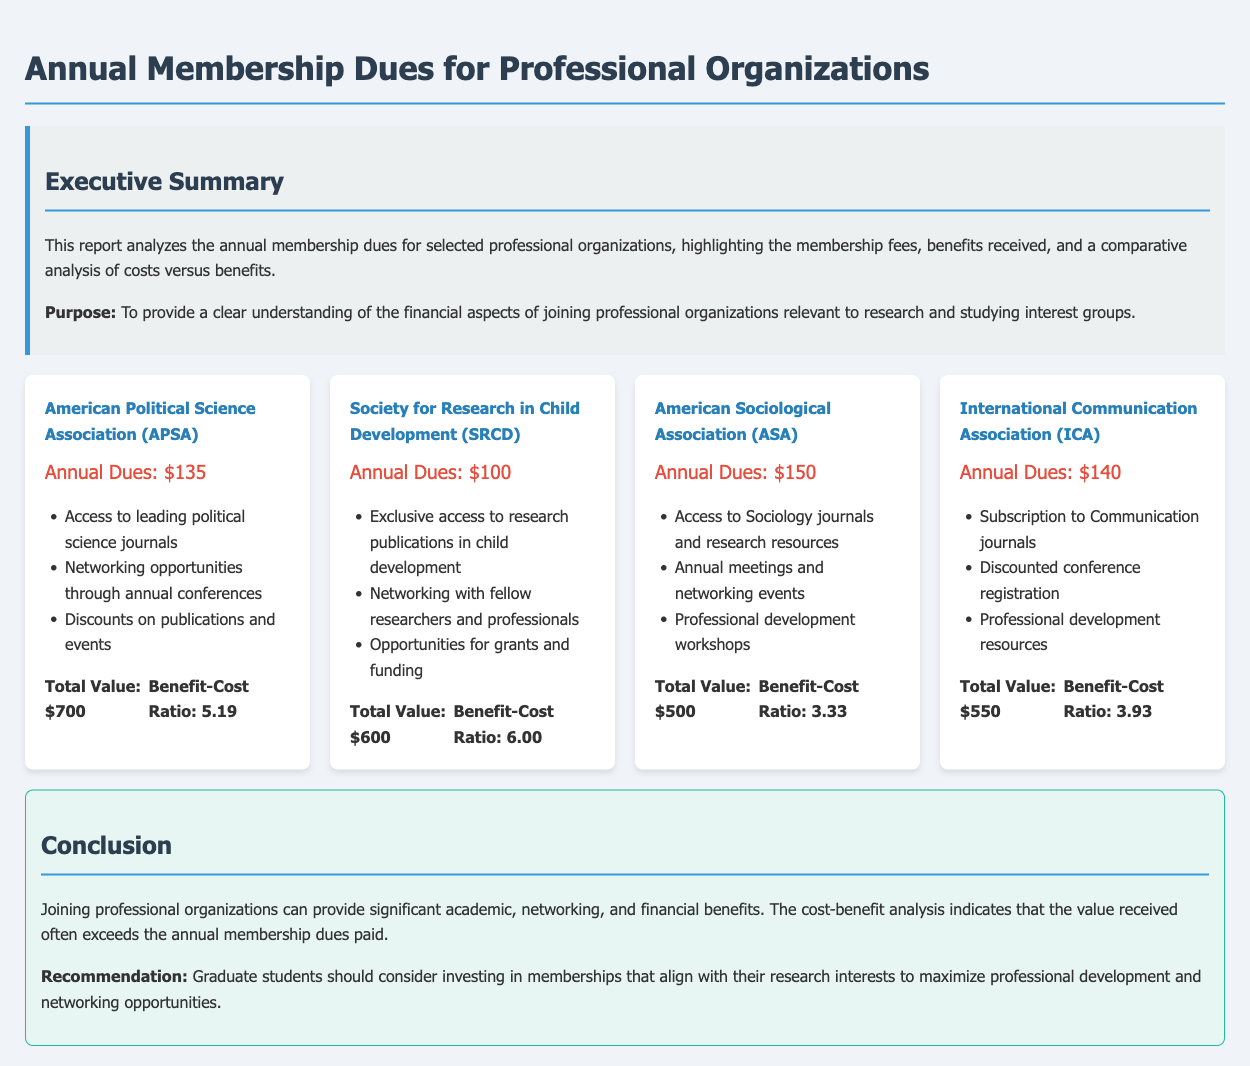What are the annual dues for APSA? The annual dues for the American Political Science Association (APSA) are clearly stated in the document.
Answer: $135 What benefits do members receive from SRCD? The benefits for members of the Society for Research in Child Development (SRCD) include detailed listings in the document.
Answer: Exclusive access to research publications in child development, Networking with fellow researchers and professionals, Opportunities for grants and funding What is the benefit-cost ratio for ASA? The benefit-cost ratio for the American Sociological Association (ASA) is calculated based on the total value received divided by the dues paid.
Answer: 3.33 Which organization has the highest total value of benefits? The organization with the highest total value of benefits is the one highlighted in the analysis section of the document.
Answer: American Political Science Association (APSA) What is the purpose of the report? The purpose of the report is explicitly mentioned in the executive summary section of the document.
Answer: To provide a clear understanding of the financial aspects of joining professional organizations relevant to research and studying interest groups What is the annual dues for ICA? The annual dues for the International Communication Association (ICA) are listed in the document.
Answer: $140 